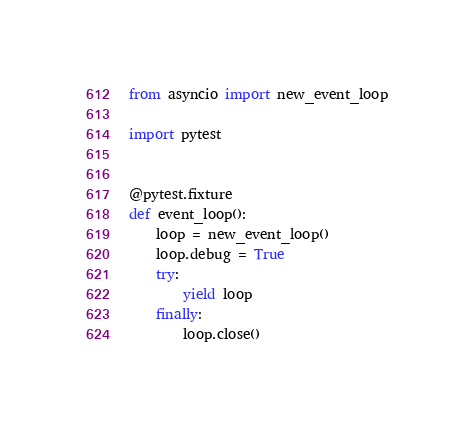<code> <loc_0><loc_0><loc_500><loc_500><_Python_>from asyncio import new_event_loop

import pytest


@pytest.fixture
def event_loop():
    loop = new_event_loop()
    loop.debug = True
    try:
        yield loop
    finally:
        loop.close()
</code> 